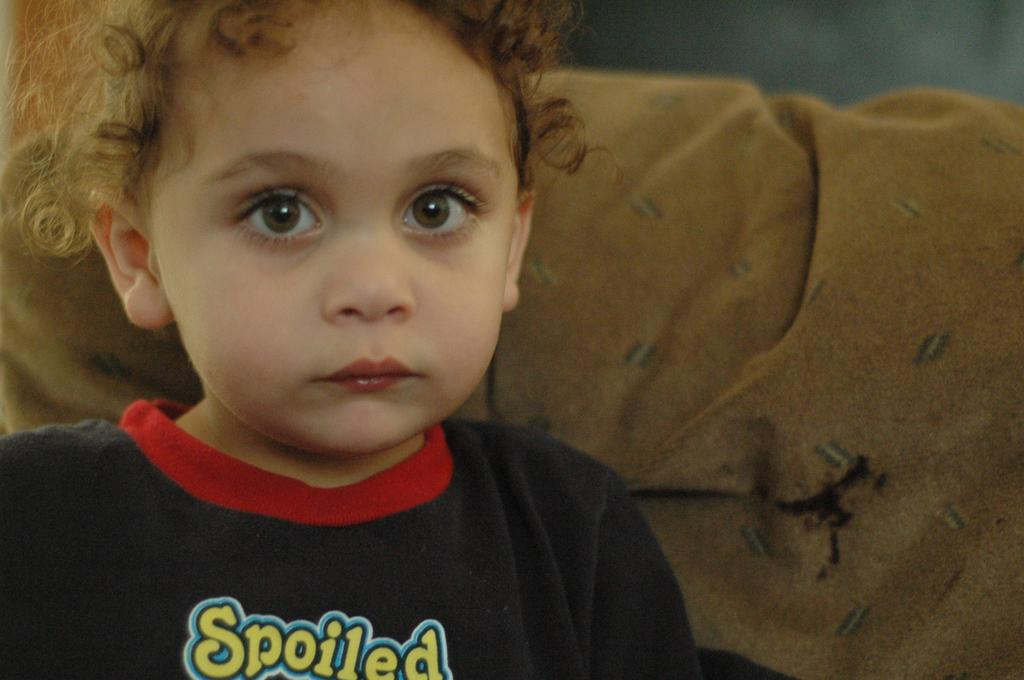What is the main subject of the picture? The main subject of the picture is a boy. Can you describe the boy's facial expression? The boy has a cute smile. What is the boy wearing in the picture? The boy is wearing a black T-shirt. What can be seen behind the boy in the picture? There is a background in the picture. What might the boy be sitting on in the picture? The boy might be sitting on a sofa. Can you tell me how many houses are visible in the picture? There are no houses visible in the picture; it features a boy with a smile. What type of toothbrush is the boy using in the picture? There is no toothbrush present in the picture; the boy is wearing a black T-shirt and has a smile. 